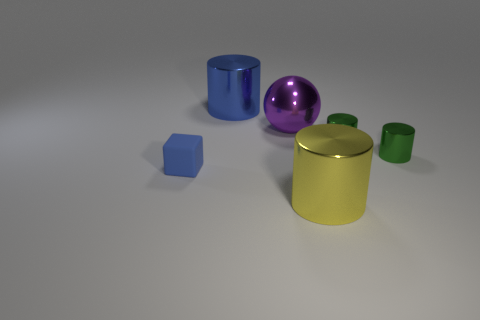Which two objects are closest to each other in the picture? The two objects that are closest to each other are the small green cylinder and the yellow cylinder. They are positioned right next to each other towards the center of the image. What could be the relationship between these two objects? Considering their proximity and similar cylindrical shape, it's possible that they could be part of a set or collection. They might represent containers of varying sizes in a stylized kitchen set, for artistic purposes, or simply objects placed together to compare dimensions and colors. 